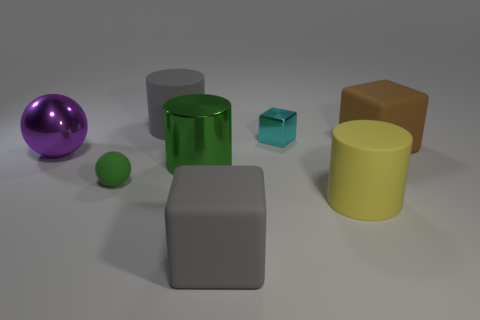Are there the same number of large things to the left of the gray cube and shiny balls that are to the right of the small cyan cube?
Make the answer very short. No. What size is the gray rubber object in front of the small ball that is in front of the purple object?
Ensure brevity in your answer.  Large. What is the big cylinder that is both in front of the brown matte object and left of the tiny cyan metallic object made of?
Offer a terse response. Metal. What number of other things are the same size as the gray rubber block?
Ensure brevity in your answer.  5. The metal sphere is what color?
Your response must be concise. Purple. There is a rubber cube behind the gray matte cube; is it the same color as the tiny metallic thing behind the tiny green rubber thing?
Provide a succinct answer. No. What is the size of the purple metallic sphere?
Provide a succinct answer. Large. What size is the ball behind the green matte ball?
Offer a very short reply. Large. The thing that is behind the tiny green rubber ball and left of the big gray cylinder has what shape?
Offer a terse response. Sphere. What number of other things are the same shape as the small green thing?
Give a very brief answer. 1. 